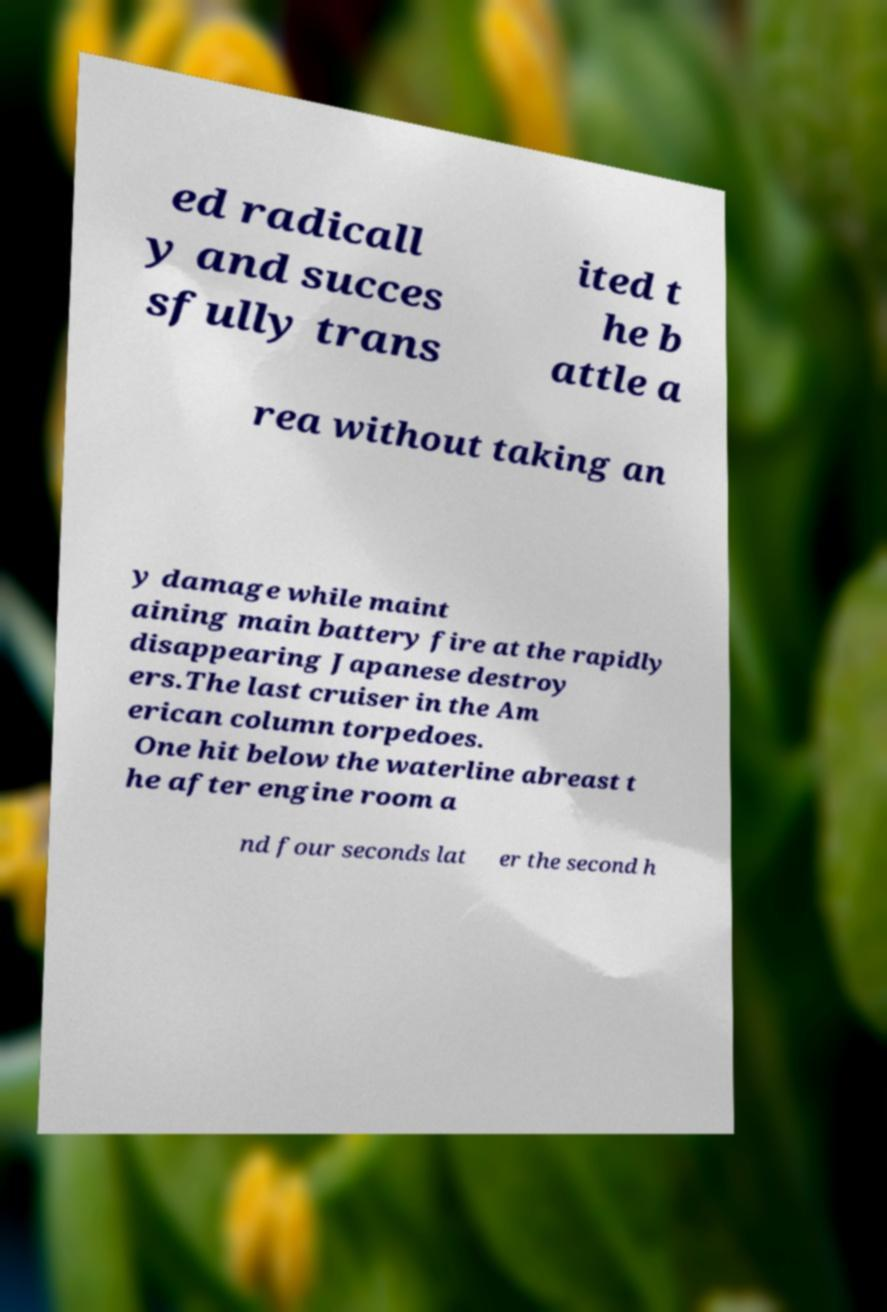For documentation purposes, I need the text within this image transcribed. Could you provide that? ed radicall y and succes sfully trans ited t he b attle a rea without taking an y damage while maint aining main battery fire at the rapidly disappearing Japanese destroy ers.The last cruiser in the Am erican column torpedoes. One hit below the waterline abreast t he after engine room a nd four seconds lat er the second h 